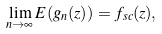Convert formula to latex. <formula><loc_0><loc_0><loc_500><loc_500>\lim _ { n \rightarrow \infty } E ( g _ { n } ( z ) ) = f _ { s c } ( z ) ,</formula> 